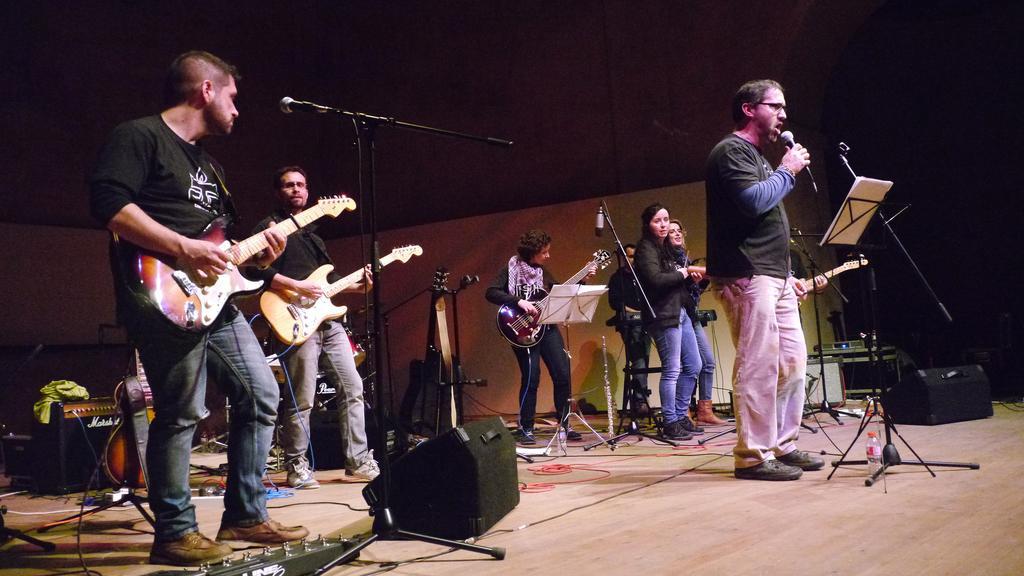Can you describe this image briefly? This image is clicked at a concert. In the image that few musicians and few singers. The people at the behind and playing acoustic guitars. The man in the center is holding a microphone in his hand and singing. In front of him there is a book holder. On the floor the speakers, boxes, cables, microphones and microphone stands. In the background there is wall. 